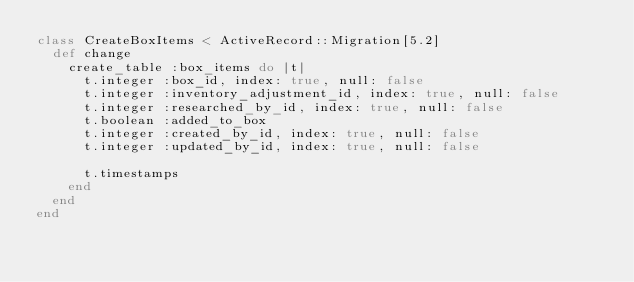<code> <loc_0><loc_0><loc_500><loc_500><_Ruby_>class CreateBoxItems < ActiveRecord::Migration[5.2]
  def change
    create_table :box_items do |t|
      t.integer :box_id, index: true, null: false
      t.integer :inventory_adjustment_id, index: true, null: false
      t.integer :researched_by_id, index: true, null: false
      t.boolean :added_to_box
      t.integer :created_by_id, index: true, null: false
      t.integer :updated_by_id, index: true, null: false

      t.timestamps
    end
  end
end
</code> 